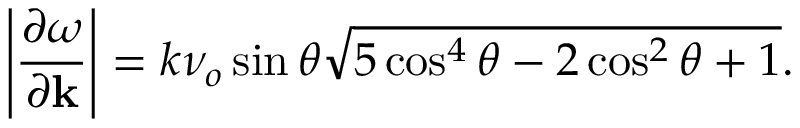Convert formula to latex. <formula><loc_0><loc_0><loc_500><loc_500>\left | \frac { \partial \omega } { \partial k } \right | = k \nu _ { o } \sin \theta \sqrt { 5 \cos ^ { 4 } \theta - 2 \cos ^ { 2 } \theta + 1 } .</formula> 